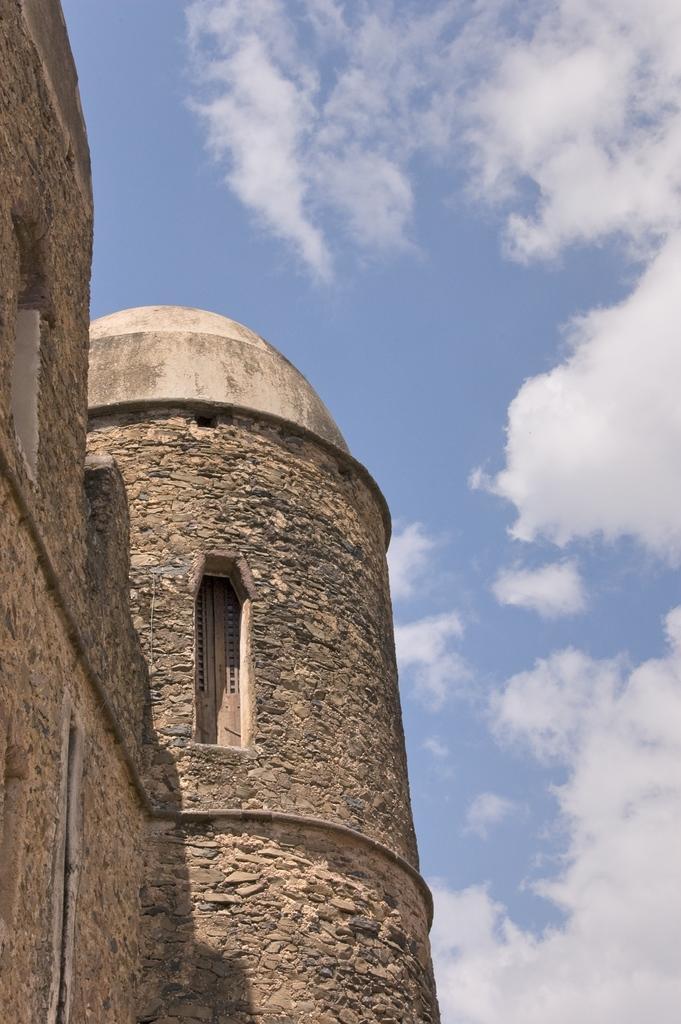Can you describe this image briefly? In this image we can see a building with windows. In the background of the image there is sky and clouds. 